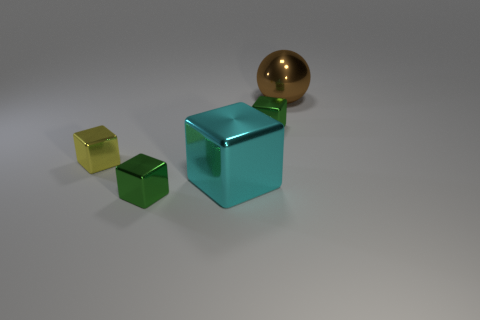There is a object that is both to the left of the large brown metal thing and behind the yellow metal block; what is its color?
Offer a very short reply. Green. Is there anything else that has the same material as the brown ball?
Offer a very short reply. Yes. Is the yellow cube made of the same material as the green object that is to the right of the cyan thing?
Make the answer very short. Yes. How big is the metal object that is to the right of the green shiny block that is on the right side of the cyan metal object?
Ensure brevity in your answer.  Large. Is there any other thing that is the same color as the big metallic cube?
Your answer should be very brief. No. Are the large thing that is in front of the ball and the green block that is behind the cyan object made of the same material?
Provide a short and direct response. Yes. What is the material of the thing that is in front of the big brown shiny object and right of the large cyan metal block?
Give a very brief answer. Metal. Is the shape of the small yellow shiny object the same as the big shiny object left of the big brown metal thing?
Your response must be concise. Yes. The green block that is behind the tiny metal object that is to the left of the small green cube that is on the left side of the cyan metal block is made of what material?
Offer a very short reply. Metal. How many other objects are the same size as the brown thing?
Offer a very short reply. 1. 